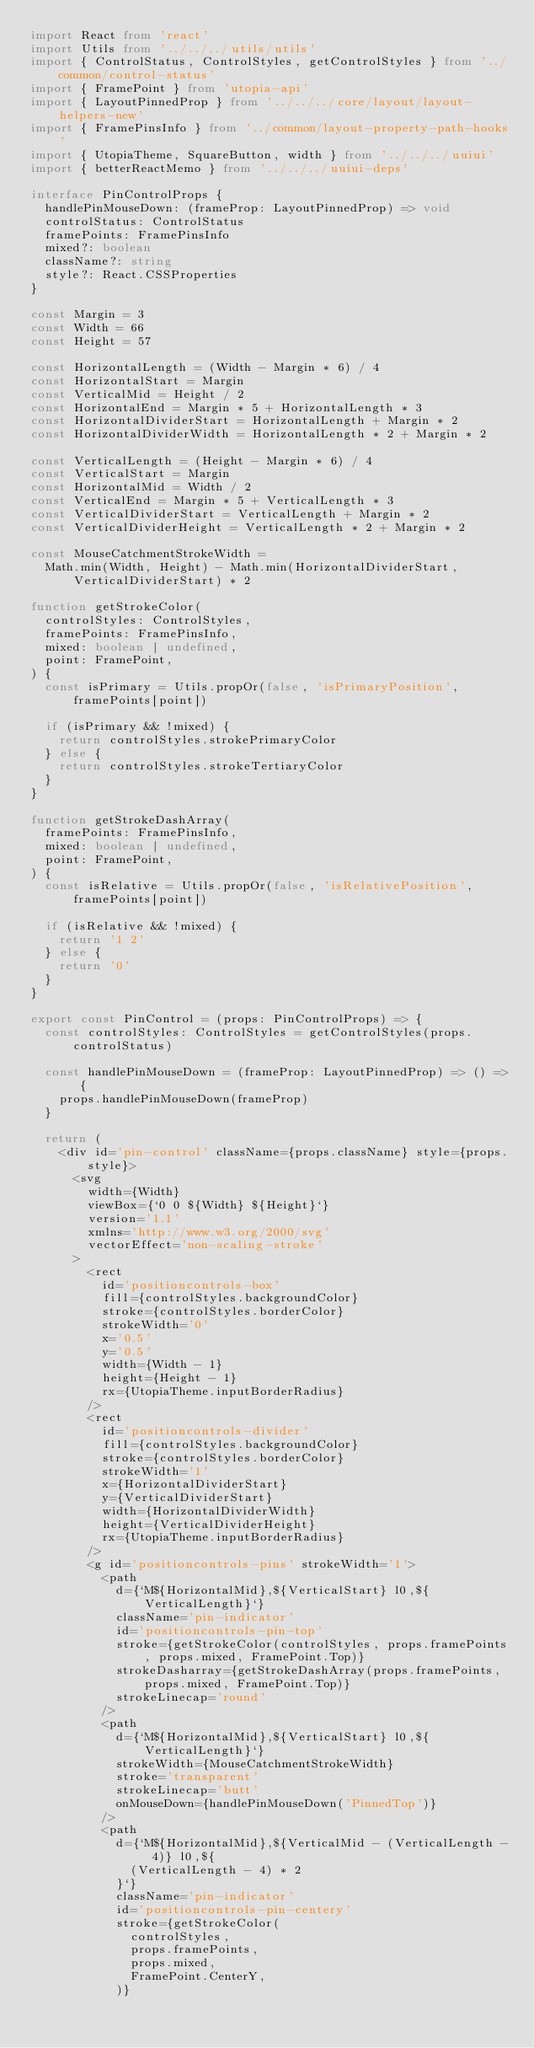<code> <loc_0><loc_0><loc_500><loc_500><_TypeScript_>import React from 'react'
import Utils from '../../../utils/utils'
import { ControlStatus, ControlStyles, getControlStyles } from '../common/control-status'
import { FramePoint } from 'utopia-api'
import { LayoutPinnedProp } from '../../../core/layout/layout-helpers-new'
import { FramePinsInfo } from '../common/layout-property-path-hooks'
import { UtopiaTheme, SquareButton, width } from '../../../uuiui'
import { betterReactMemo } from '../../../uuiui-deps'

interface PinControlProps {
  handlePinMouseDown: (frameProp: LayoutPinnedProp) => void
  controlStatus: ControlStatus
  framePoints: FramePinsInfo
  mixed?: boolean
  className?: string
  style?: React.CSSProperties
}

const Margin = 3
const Width = 66
const Height = 57

const HorizontalLength = (Width - Margin * 6) / 4
const HorizontalStart = Margin
const VerticalMid = Height / 2
const HorizontalEnd = Margin * 5 + HorizontalLength * 3
const HorizontalDividerStart = HorizontalLength + Margin * 2
const HorizontalDividerWidth = HorizontalLength * 2 + Margin * 2

const VerticalLength = (Height - Margin * 6) / 4
const VerticalStart = Margin
const HorizontalMid = Width / 2
const VerticalEnd = Margin * 5 + VerticalLength * 3
const VerticalDividerStart = VerticalLength + Margin * 2
const VerticalDividerHeight = VerticalLength * 2 + Margin * 2

const MouseCatchmentStrokeWidth =
  Math.min(Width, Height) - Math.min(HorizontalDividerStart, VerticalDividerStart) * 2

function getStrokeColor(
  controlStyles: ControlStyles,
  framePoints: FramePinsInfo,
  mixed: boolean | undefined,
  point: FramePoint,
) {
  const isPrimary = Utils.propOr(false, 'isPrimaryPosition', framePoints[point])

  if (isPrimary && !mixed) {
    return controlStyles.strokePrimaryColor
  } else {
    return controlStyles.strokeTertiaryColor
  }
}

function getStrokeDashArray(
  framePoints: FramePinsInfo,
  mixed: boolean | undefined,
  point: FramePoint,
) {
  const isRelative = Utils.propOr(false, 'isRelativePosition', framePoints[point])

  if (isRelative && !mixed) {
    return '1 2'
  } else {
    return '0'
  }
}

export const PinControl = (props: PinControlProps) => {
  const controlStyles: ControlStyles = getControlStyles(props.controlStatus)

  const handlePinMouseDown = (frameProp: LayoutPinnedProp) => () => {
    props.handlePinMouseDown(frameProp)
  }

  return (
    <div id='pin-control' className={props.className} style={props.style}>
      <svg
        width={Width}
        viewBox={`0 0 ${Width} ${Height}`}
        version='1.1'
        xmlns='http://www.w3.org/2000/svg'
        vectorEffect='non-scaling-stroke'
      >
        <rect
          id='positioncontrols-box'
          fill={controlStyles.backgroundColor}
          stroke={controlStyles.borderColor}
          strokeWidth='0'
          x='0.5'
          y='0.5'
          width={Width - 1}
          height={Height - 1}
          rx={UtopiaTheme.inputBorderRadius}
        />
        <rect
          id='positioncontrols-divider'
          fill={controlStyles.backgroundColor}
          stroke={controlStyles.borderColor}
          strokeWidth='1'
          x={HorizontalDividerStart}
          y={VerticalDividerStart}
          width={HorizontalDividerWidth}
          height={VerticalDividerHeight}
          rx={UtopiaTheme.inputBorderRadius}
        />
        <g id='positioncontrols-pins' strokeWidth='1'>
          <path
            d={`M${HorizontalMid},${VerticalStart} l0,${VerticalLength}`}
            className='pin-indicator'
            id='positioncontrols-pin-top'
            stroke={getStrokeColor(controlStyles, props.framePoints, props.mixed, FramePoint.Top)}
            strokeDasharray={getStrokeDashArray(props.framePoints, props.mixed, FramePoint.Top)}
            strokeLinecap='round'
          />
          <path
            d={`M${HorizontalMid},${VerticalStart} l0,${VerticalLength}`}
            strokeWidth={MouseCatchmentStrokeWidth}
            stroke='transparent'
            strokeLinecap='butt'
            onMouseDown={handlePinMouseDown('PinnedTop')}
          />
          <path
            d={`M${HorizontalMid},${VerticalMid - (VerticalLength - 4)} l0,${
              (VerticalLength - 4) * 2
            }`}
            className='pin-indicator'
            id='positioncontrols-pin-centery'
            stroke={getStrokeColor(
              controlStyles,
              props.framePoints,
              props.mixed,
              FramePoint.CenterY,
            )}</code> 